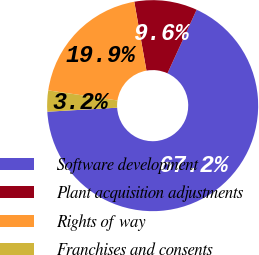<chart> <loc_0><loc_0><loc_500><loc_500><pie_chart><fcel>Software development<fcel>Plant acquisition adjustments<fcel>Rights of way<fcel>Franchises and consents<nl><fcel>67.24%<fcel>9.63%<fcel>19.9%<fcel>3.23%<nl></chart> 